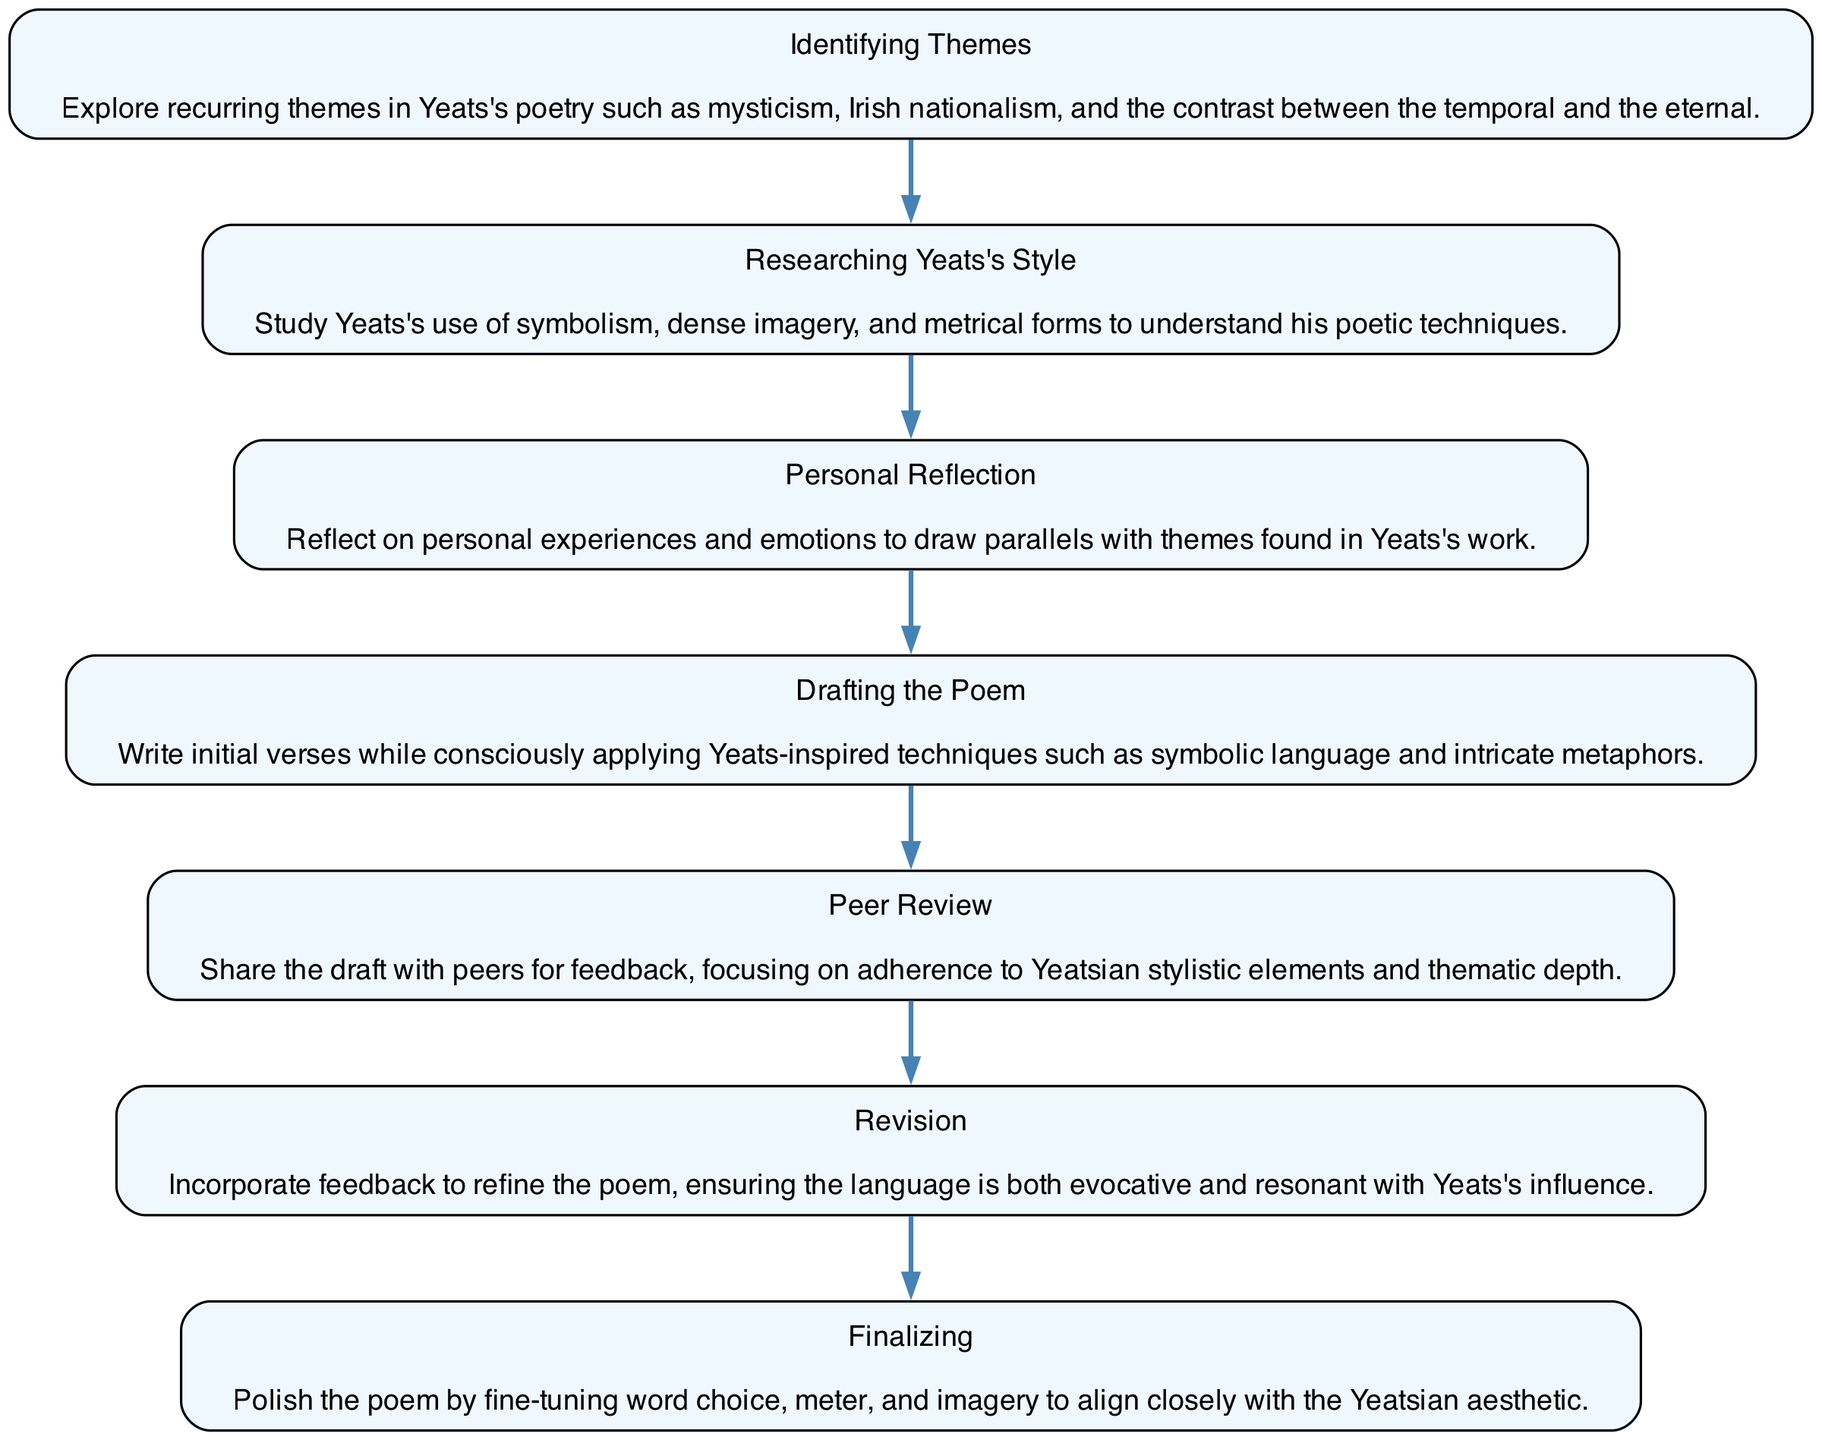What is the first step in the diagram? The diagram starts with the "Identifying Themes" step, as it is the first node in the flow.
Answer: Identifying Themes How many steps are there in total? Counting all the nodes listed in the flow chart reveals that there are a total of 7 steps.
Answer: 7 What step comes after "Researching Yeats's Style"? The flow of the diagram shows that the step immediately following "Researching Yeats's Style" is "Personal Reflection."
Answer: Personal Reflection Which step emphasizes sharing drafts for feedback? The diagram indicates that "Peer Review" is the step that involves sharing the draft for peer feedback.
Answer: Peer Review What is the final step in the creative process? According to the diagram, the last step to be completed is "Finalizing."
Answer: Finalizing Which two steps focus on improvement of the poem? Upon reviewing the flow, "Peer Review" and "Revision" are the two steps focused on improving the poem through feedback and refinement.
Answer: Peer Review, Revision How do "Drafting the Poem" and "Researching Yeats's Style" connect? The diagram illustrates a direct progression where "Researching Yeats's Style" must be completed before "Drafting the Poem," indicating a logical flow from understanding to creation.
Answer: Through a sequential progression What is the purpose of the "Personal Reflection" step? "Personal Reflection" serves as a bridge between Yeats's themes and the writer's own experiences, allowing for a deeper connection to Yeats's work.
Answer: To connect personal experiences with Yeats's themes 